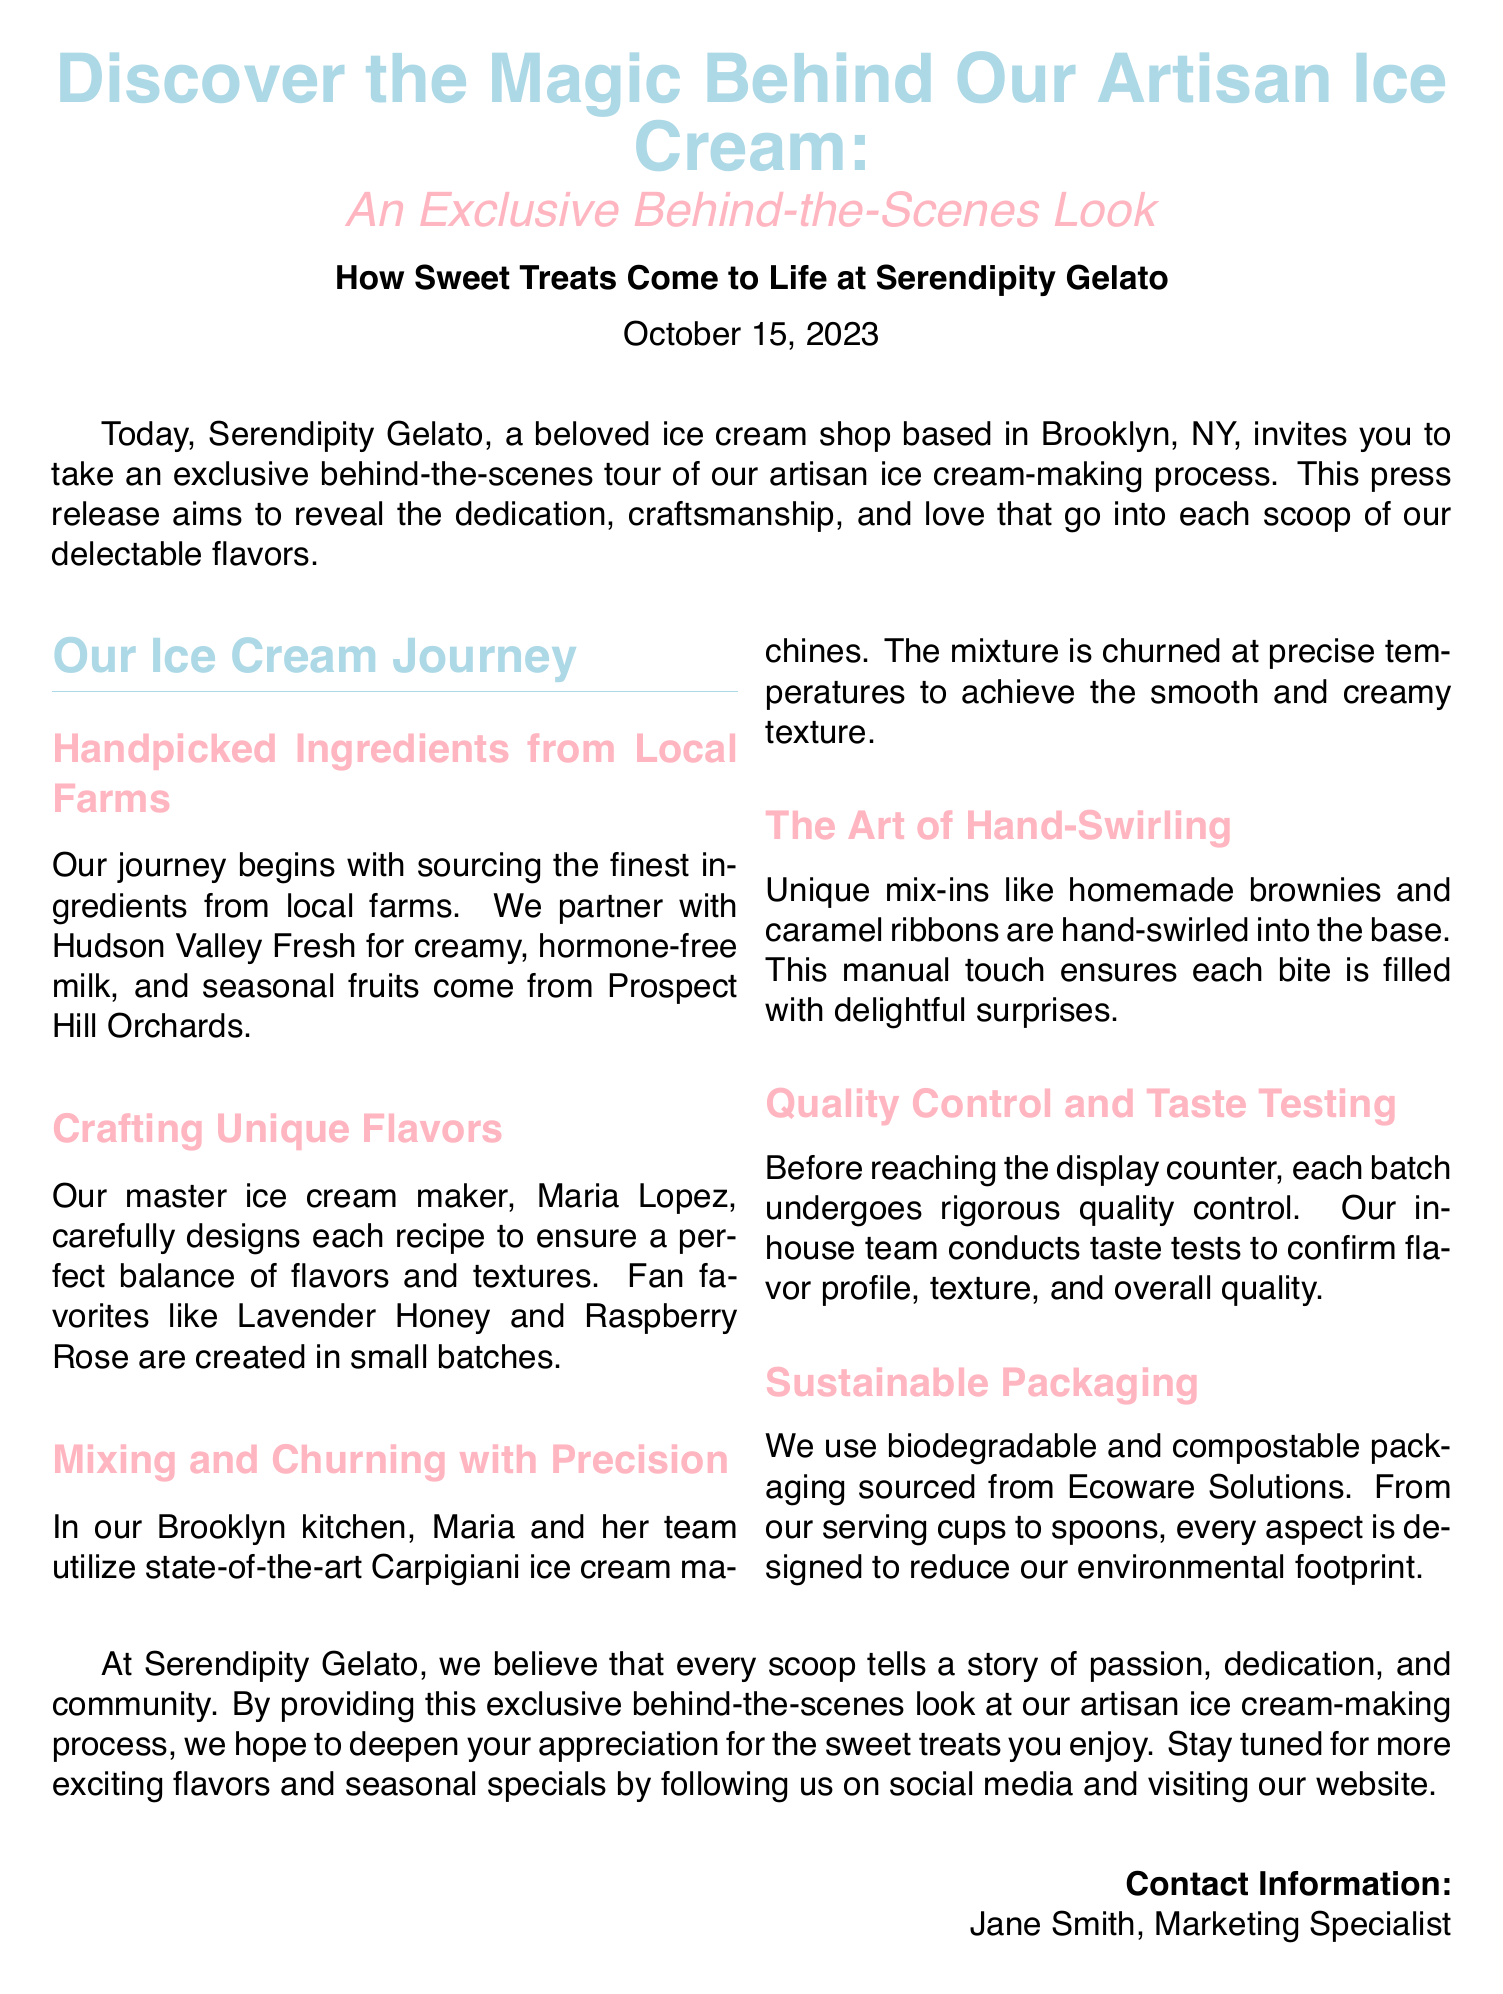What is the title of the press release? The title can be found at the top of the document, summarizing the content.
Answer: Discover the Magic Behind Our Artisan Ice Cream Who is the master ice cream maker? This detail is located in the section about crafting unique flavors.
Answer: Maria Lopez What type of milk do they use? This information is mentioned under the handpicked ingredients section.
Answer: hormone-free milk What flavors are mentioned as fan favorites? The press release specifies certain flavors that are popular among customers.
Answer: Lavender Honey and Raspberry Rose What company provides the packaging? The document states the name of the company that supplies their sustainable packaging.
Answer: Ecoware Solutions How often is the ice cream crafted? This question relates to how the ice cream is produced based on the artisan approach specified in the document.
Answer: in small batches What city is Serendipity Gelato located in? The location of the ice cream shop is mentioned in the contact information section.
Answer: Brooklyn What does each batch undergo before reaching the display counter? This is addressed in the quality control section of the document.
Answer: rigorous quality control When was the press release issued? The date of the press release is given near the beginning of the document.
Answer: October 15, 2023 